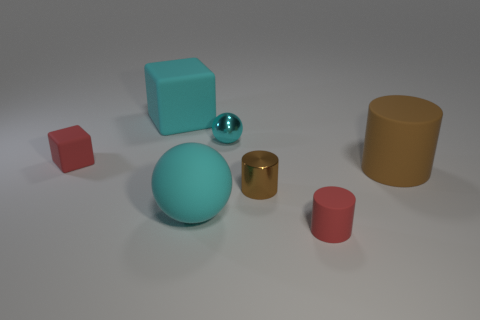The large brown matte object is what shape?
Ensure brevity in your answer.  Cylinder. How many other things are there of the same material as the small sphere?
Make the answer very short. 1. There is another brown object that is the same shape as the small brown object; what is its size?
Keep it short and to the point. Large. What material is the tiny thing on the left side of the cyan rubber cube left of the red object that is to the right of the big cyan rubber block?
Give a very brief answer. Rubber. Are there any small objects?
Make the answer very short. Yes. Does the big rubber cylinder have the same color as the sphere behind the red cube?
Provide a succinct answer. No. The tiny shiny cylinder is what color?
Your answer should be compact. Brown. Are there any other things that have the same shape as the small brown object?
Provide a succinct answer. Yes. There is a tiny metal thing that is the same shape as the big brown object; what is its color?
Offer a terse response. Brown. Is the shape of the large brown rubber object the same as the brown metallic thing?
Your answer should be very brief. Yes. 